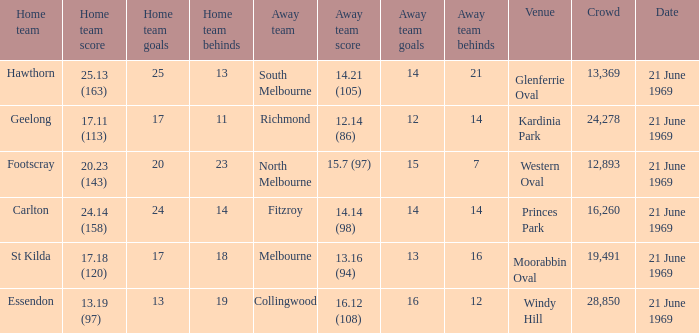When did an away team score 15.7 (97)? 21 June 1969. 